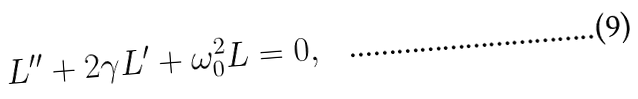<formula> <loc_0><loc_0><loc_500><loc_500>L ^ { \prime \prime } + 2 \gamma L ^ { \prime } + \omega _ { 0 } ^ { 2 } L = 0 ,</formula> 